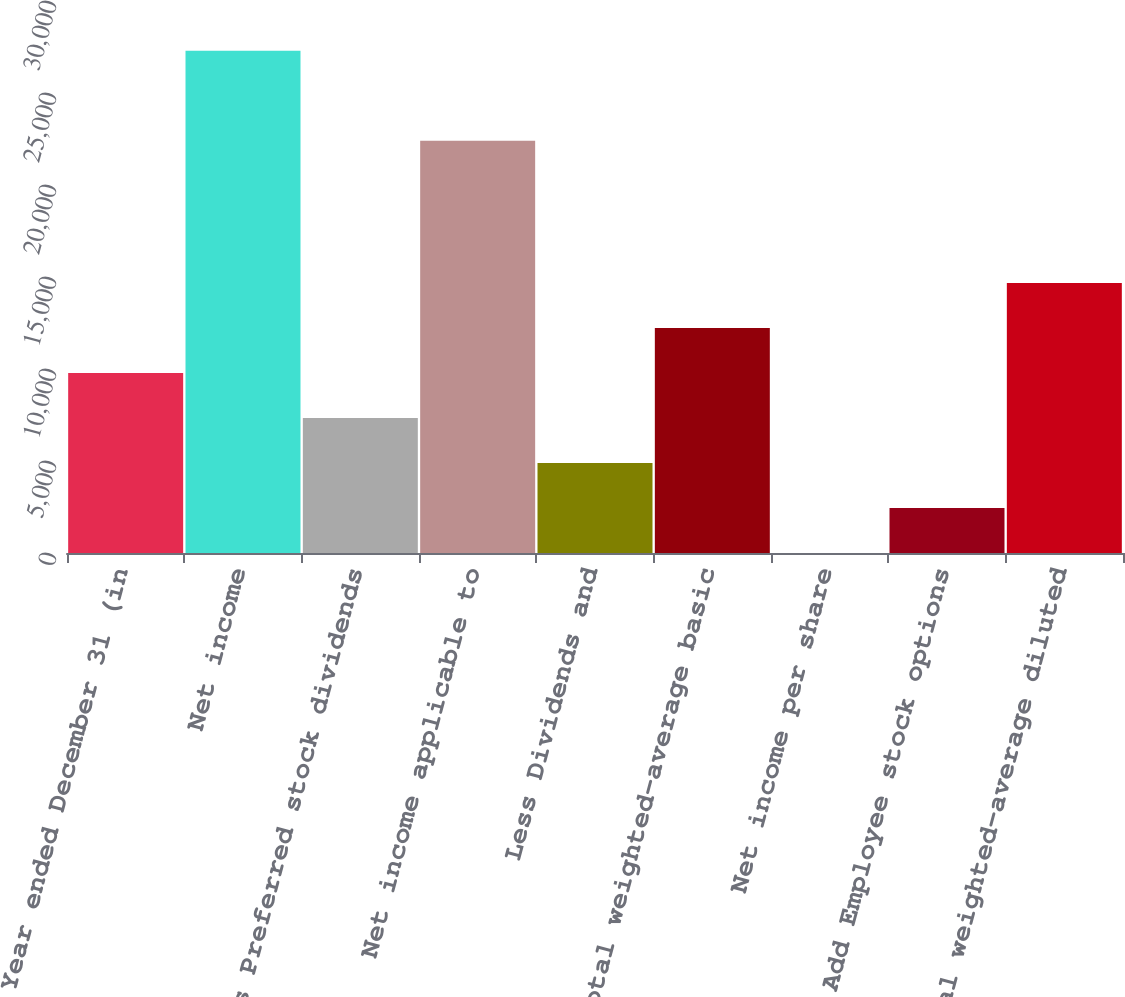<chart> <loc_0><loc_0><loc_500><loc_500><bar_chart><fcel>Year ended December 31 (in<fcel>Net income<fcel>Less Preferred stock dividends<fcel>Net income applicable to<fcel>Less Dividends and<fcel>Total weighted-average basic<fcel>Net income per share<fcel>Add Employee stock options<fcel>Total weighted-average diluted<nl><fcel>9780.44<fcel>27293.2<fcel>7336.85<fcel>22406<fcel>4893.25<fcel>12224<fcel>6.05<fcel>2449.65<fcel>14667.6<nl></chart> 